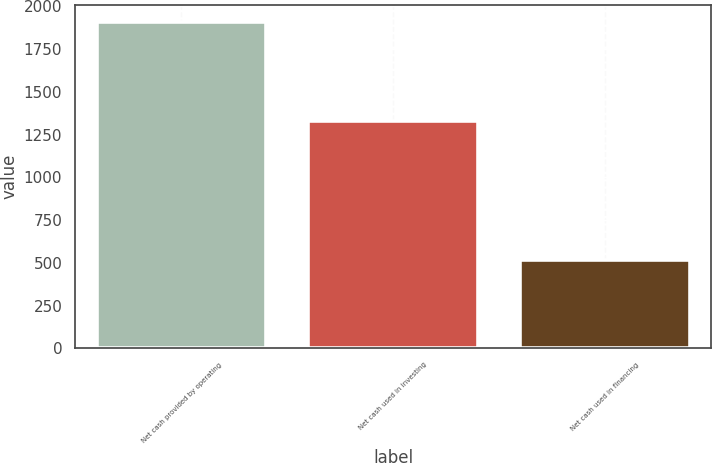Convert chart. <chart><loc_0><loc_0><loc_500><loc_500><bar_chart><fcel>Net cash provided by operating<fcel>Net cash used in investing<fcel>Net cash used in financing<nl><fcel>1910.7<fcel>1330.2<fcel>514.4<nl></chart> 